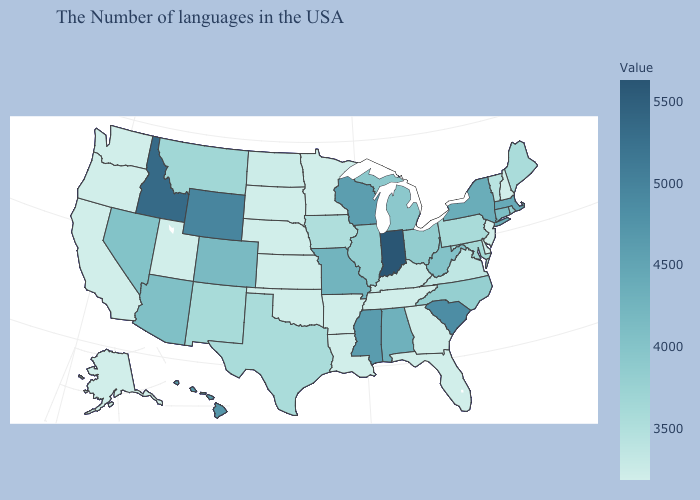Does Wyoming have the highest value in the West?
Concise answer only. No. Does Idaho have a higher value than Montana?
Answer briefly. Yes. Among the states that border West Virginia , does Ohio have the highest value?
Quick response, please. Yes. Among the states that border Virginia , which have the lowest value?
Answer briefly. Tennessee. Among the states that border Texas , which have the highest value?
Write a very short answer. New Mexico. Does New Hampshire have the lowest value in the Northeast?
Quick response, please. Yes. 